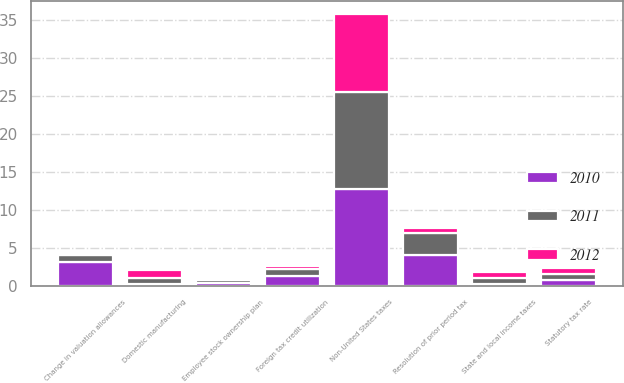Convert chart. <chart><loc_0><loc_0><loc_500><loc_500><stacked_bar_chart><ecel><fcel>Statutory tax rate<fcel>State and local income taxes<fcel>Non-United States taxes<fcel>Foreign tax credit utilization<fcel>Employee stock ownership plan<fcel>Change in valuation allowances<fcel>Domestic manufacturing<fcel>Resolution of prior period tax<nl><fcel>2012<fcel>0.8<fcel>0.8<fcel>10.3<fcel>0.4<fcel>0.3<fcel>0.2<fcel>1.1<fcel>0.6<nl><fcel>2011<fcel>0.8<fcel>0.7<fcel>12.7<fcel>0.9<fcel>0.3<fcel>0.8<fcel>0.8<fcel>2.9<nl><fcel>2010<fcel>0.8<fcel>0.3<fcel>12.8<fcel>1.3<fcel>0.4<fcel>3.2<fcel>0.2<fcel>4.1<nl></chart> 